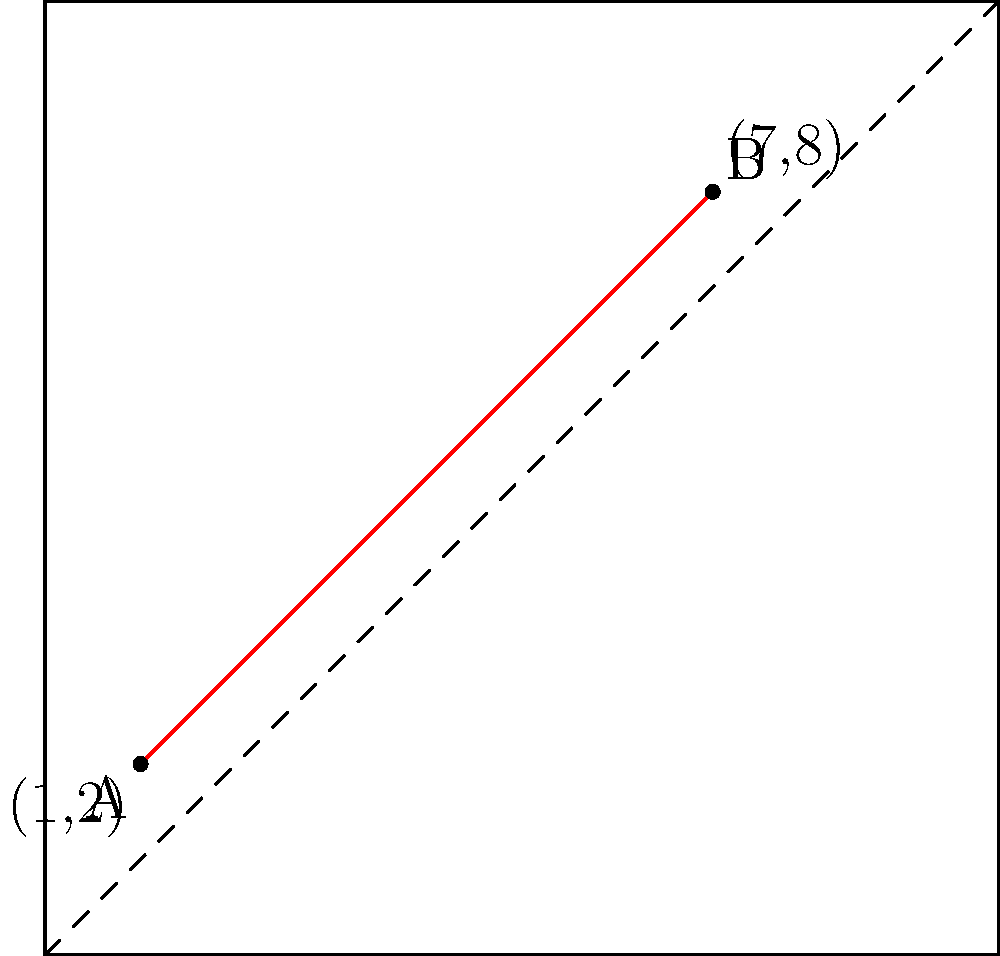On a tactical map represented by a Cartesian coordinate system, two points of interest are marked: Point A at (1,2) and Point B at (7,8). What is the shortest distance between these two points? Round your answer to two decimal places. To find the shortest distance between two points on a coordinate plane, we can use the distance formula, which is derived from the Pythagorean theorem:

$$d = \sqrt{(x_2 - x_1)^2 + (y_2 - y_1)^2}$$

Where $(x_1, y_1)$ are the coordinates of the first point and $(x_2, y_2)$ are the coordinates of the second point.

Given:
- Point A: $(x_1, y_1) = (1, 2)$
- Point B: $(x_2, y_2) = (7, 8)$

Let's plug these values into the formula:

$$\begin{align}
d &= \sqrt{(7 - 1)^2 + (8 - 2)^2} \\
&= \sqrt{6^2 + 6^2} \\
&= \sqrt{36 + 36} \\
&= \sqrt{72} \\
&= 6\sqrt{2} \\
&\approx 8.4853
\end{align}$$

Rounding to two decimal places, we get 8.49 units.

This represents the shortest distance between the two points on the tactical map, which would be a straight line connecting points A and B.
Answer: 8.49 units 